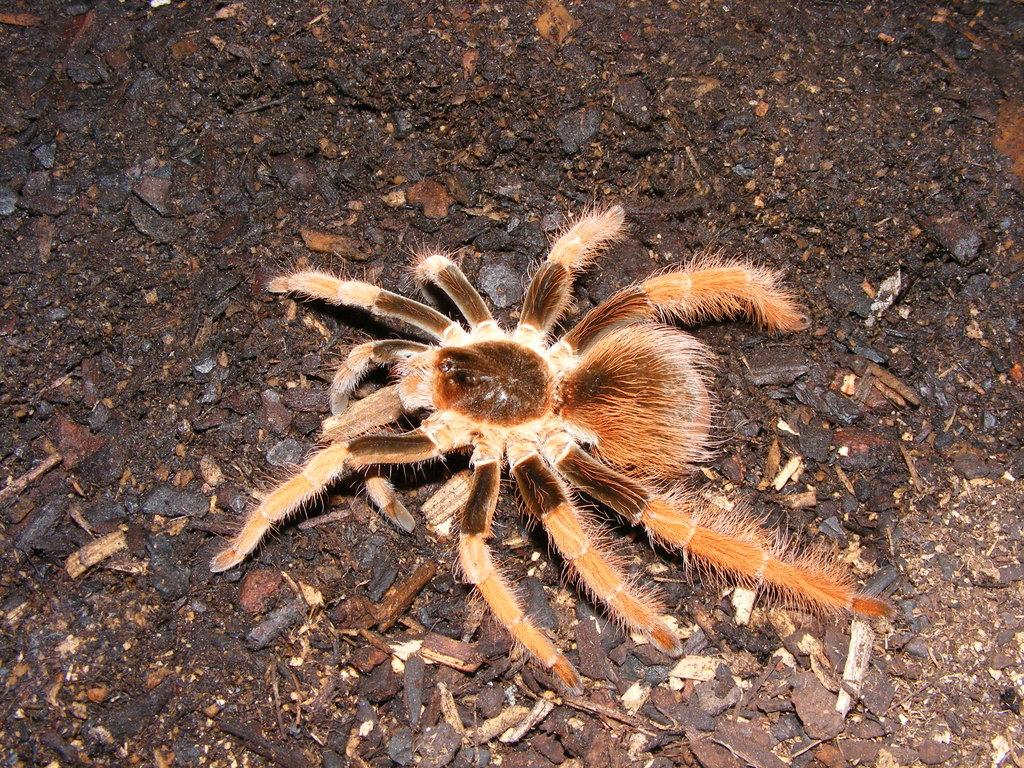What type of creature can be seen in the image? There is an insect in the image. Where is the insect located? The insect is on the ground. What is present in the area around the insect? There is a lot of dust and many waste particles around the insect. Reasoning: Let's think step by following the guidelines to produce the conversation. We start by identifying the main subject in the image, which is the insect. Then, we describe its location and the environment around it. Each question is designed to elicit a specific detail about the image that is known from the provided facts. Absurd Question/Answer: What type of books can be seen in the image? There are no books present in the image. 